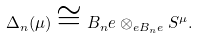<formula> <loc_0><loc_0><loc_500><loc_500>\Delta _ { n } ( \mu ) \cong B _ { n } e \otimes _ { e B _ { n } e } S ^ { \mu } .</formula> 